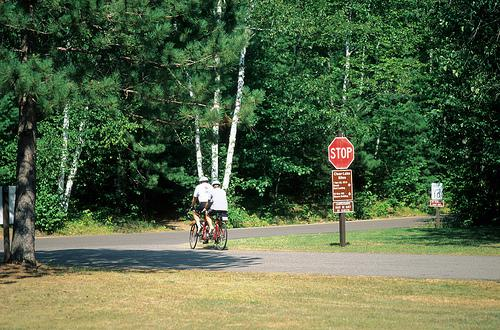Question: what are the people riding?
Choices:
A. A horse.
B. A motorcycle.
C. A bike.
D. Merry-go-round.
Answer with the letter. Answer: C Question: how many people?
Choices:
A. Two.
B. Three.
C. Four.
D. Five.
Answer with the letter. Answer: A Question: what does the red sign say?
Choices:
A. Stop.
B. Exit.
C. Caution.
D. No trespassing.
Answer with the letter. Answer: A Question: who is in the picture?
Choices:
A. Family pets.
B. Farm animals.
C. Close family.
D. People.
Answer with the letter. Answer: D 